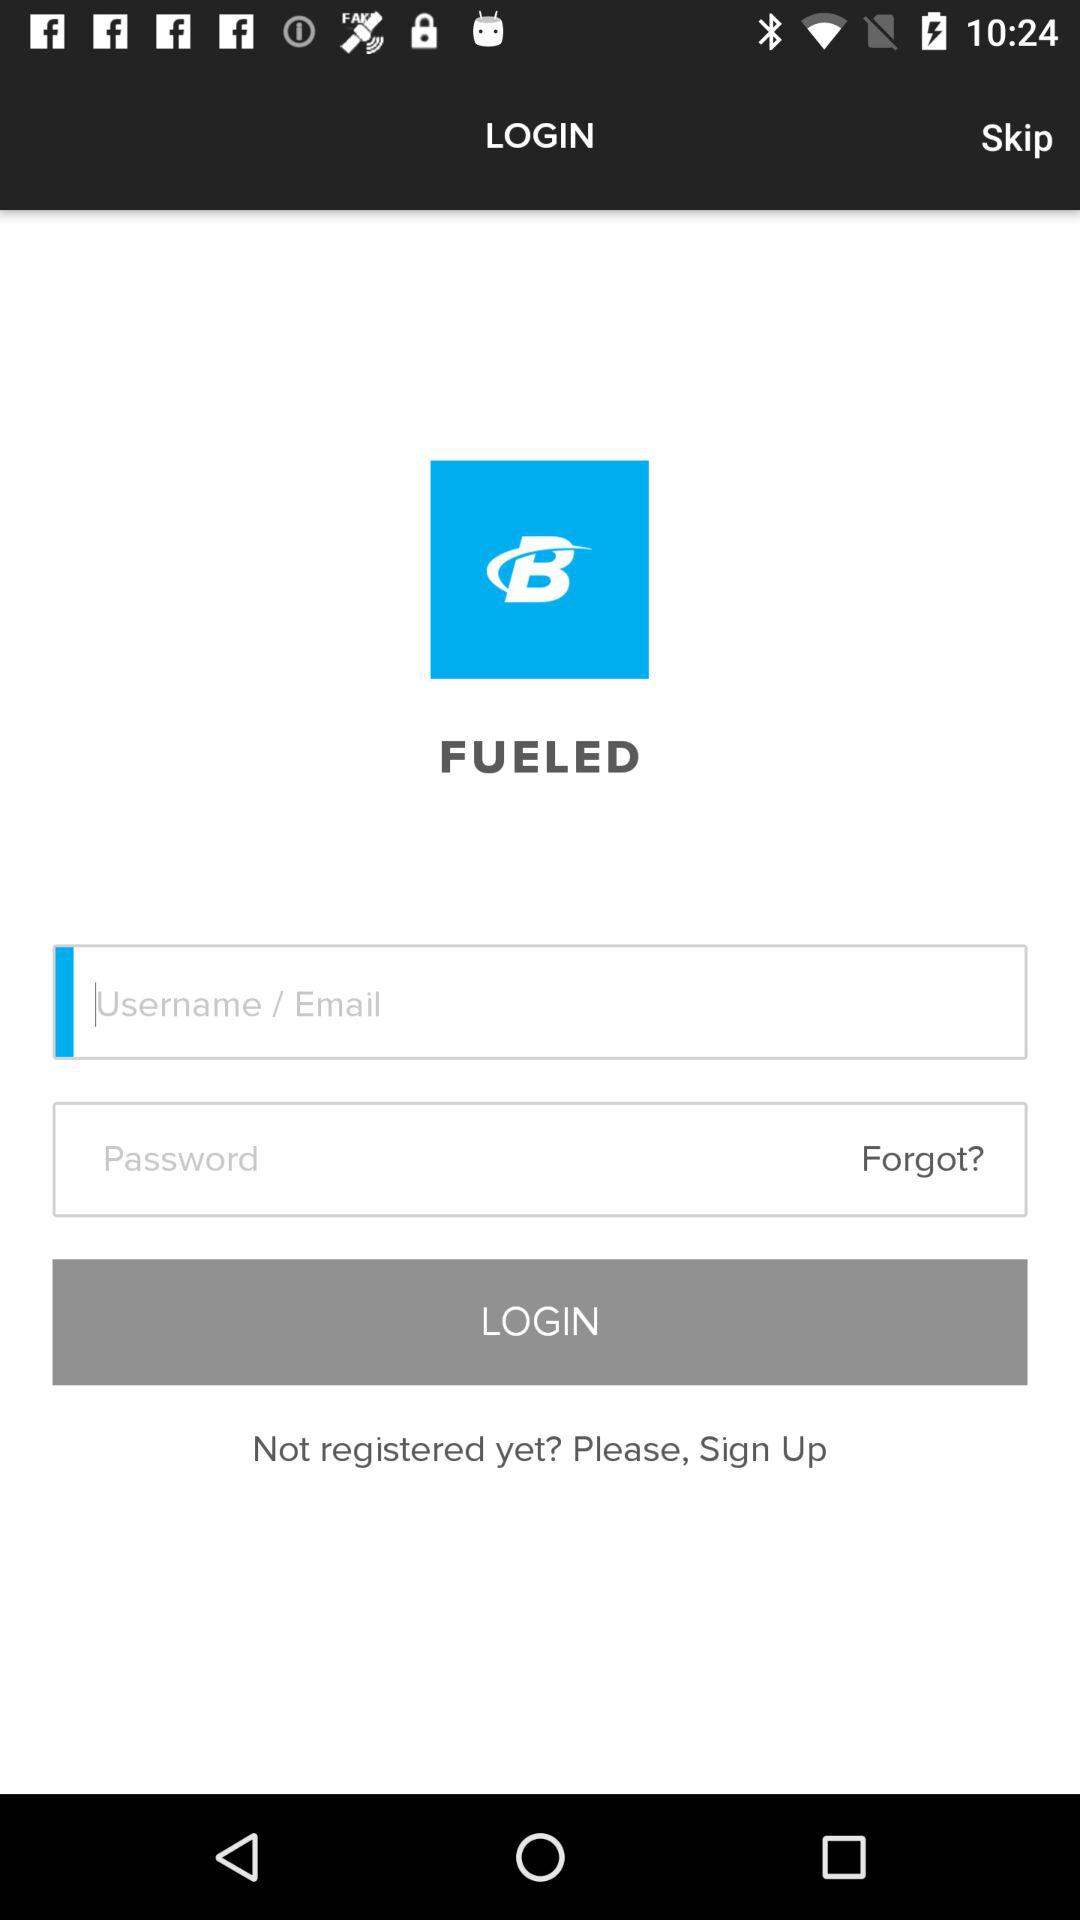What is the application name? The application name is "FUELED". 